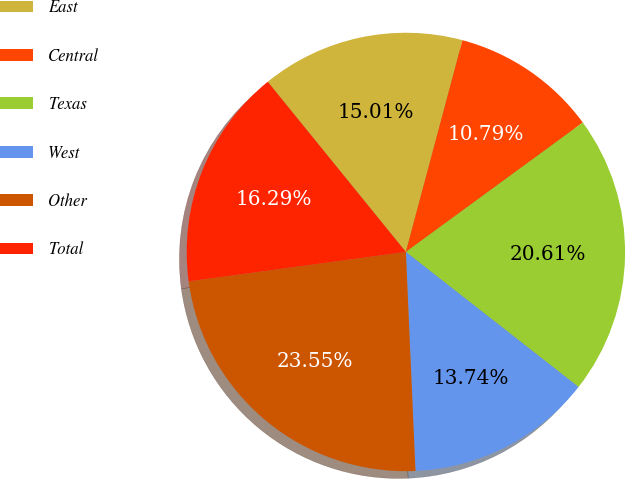<chart> <loc_0><loc_0><loc_500><loc_500><pie_chart><fcel>East<fcel>Central<fcel>Texas<fcel>West<fcel>Other<fcel>Total<nl><fcel>15.01%<fcel>10.79%<fcel>20.61%<fcel>13.74%<fcel>23.55%<fcel>16.29%<nl></chart> 